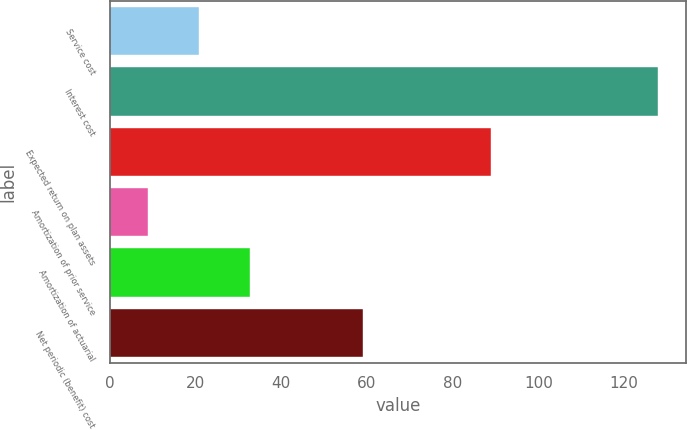Convert chart to OTSL. <chart><loc_0><loc_0><loc_500><loc_500><bar_chart><fcel>Service cost<fcel>Interest cost<fcel>Expected return on plan assets<fcel>Amortization of prior service<fcel>Amortization of actuarial<fcel>Net periodic (benefit) cost<nl><fcel>20.9<fcel>128<fcel>89<fcel>9<fcel>32.8<fcel>59<nl></chart> 